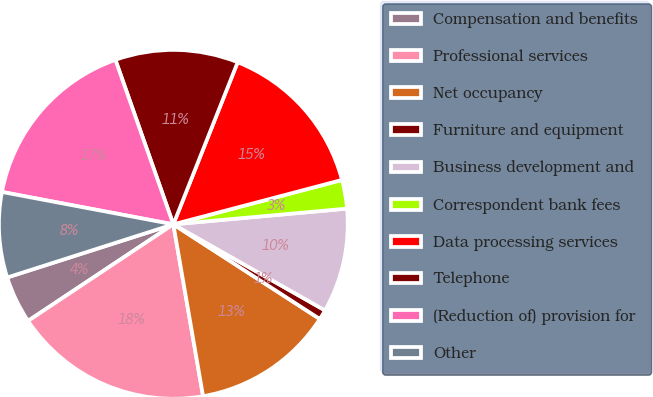<chart> <loc_0><loc_0><loc_500><loc_500><pie_chart><fcel>Compensation and benefits<fcel>Professional services<fcel>Net occupancy<fcel>Furniture and equipment<fcel>Business development and<fcel>Correspondent bank fees<fcel>Data processing services<fcel>Telephone<fcel>(Reduction of) provision for<fcel>Other<nl><fcel>4.41%<fcel>18.39%<fcel>13.14%<fcel>0.92%<fcel>9.65%<fcel>2.66%<fcel>14.89%<fcel>11.4%<fcel>16.64%<fcel>7.9%<nl></chart> 